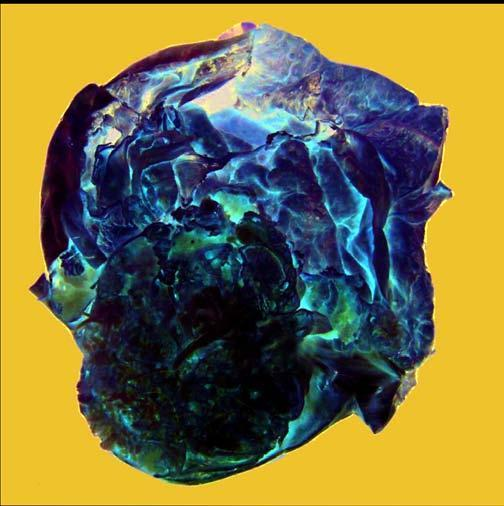what does cut surface show without papillae?
Answer the question using a single word or phrase. A very large multilocular cyst 